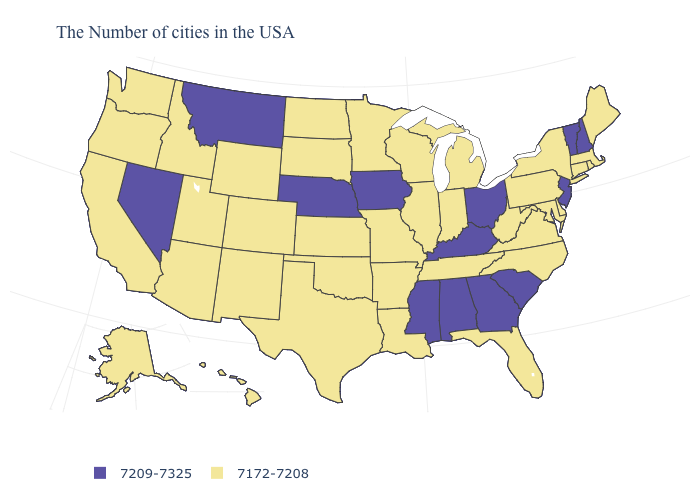What is the lowest value in the MidWest?
Be succinct. 7172-7208. What is the value of West Virginia?
Short answer required. 7172-7208. Among the states that border Idaho , which have the lowest value?
Answer briefly. Wyoming, Utah, Washington, Oregon. What is the lowest value in states that border Maine?
Write a very short answer. 7209-7325. Does Maryland have a higher value than California?
Short answer required. No. What is the value of Illinois?
Give a very brief answer. 7172-7208. Among the states that border Mississippi , does Alabama have the lowest value?
Short answer required. No. Does the first symbol in the legend represent the smallest category?
Write a very short answer. No. What is the value of Wisconsin?
Keep it brief. 7172-7208. What is the value of North Dakota?
Give a very brief answer. 7172-7208. Name the states that have a value in the range 7172-7208?
Answer briefly. Maine, Massachusetts, Rhode Island, Connecticut, New York, Delaware, Maryland, Pennsylvania, Virginia, North Carolina, West Virginia, Florida, Michigan, Indiana, Tennessee, Wisconsin, Illinois, Louisiana, Missouri, Arkansas, Minnesota, Kansas, Oklahoma, Texas, South Dakota, North Dakota, Wyoming, Colorado, New Mexico, Utah, Arizona, Idaho, California, Washington, Oregon, Alaska, Hawaii. Among the states that border Tennessee , which have the lowest value?
Quick response, please. Virginia, North Carolina, Missouri, Arkansas. What is the value of Wisconsin?
Give a very brief answer. 7172-7208. Among the states that border Georgia , does Florida have the highest value?
Be succinct. No. Name the states that have a value in the range 7209-7325?
Concise answer only. New Hampshire, Vermont, New Jersey, South Carolina, Ohio, Georgia, Kentucky, Alabama, Mississippi, Iowa, Nebraska, Montana, Nevada. 